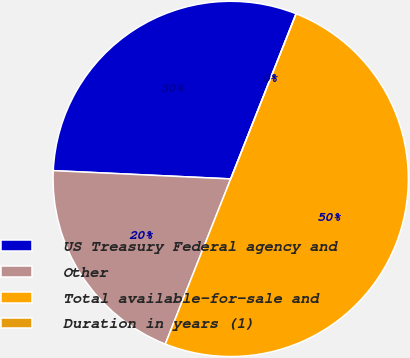<chart> <loc_0><loc_0><loc_500><loc_500><pie_chart><fcel>US Treasury Federal agency and<fcel>Other<fcel>Total available-for-sale and<fcel>Duration in years (1)<nl><fcel>30.26%<fcel>19.74%<fcel>50.0%<fcel>0.0%<nl></chart> 